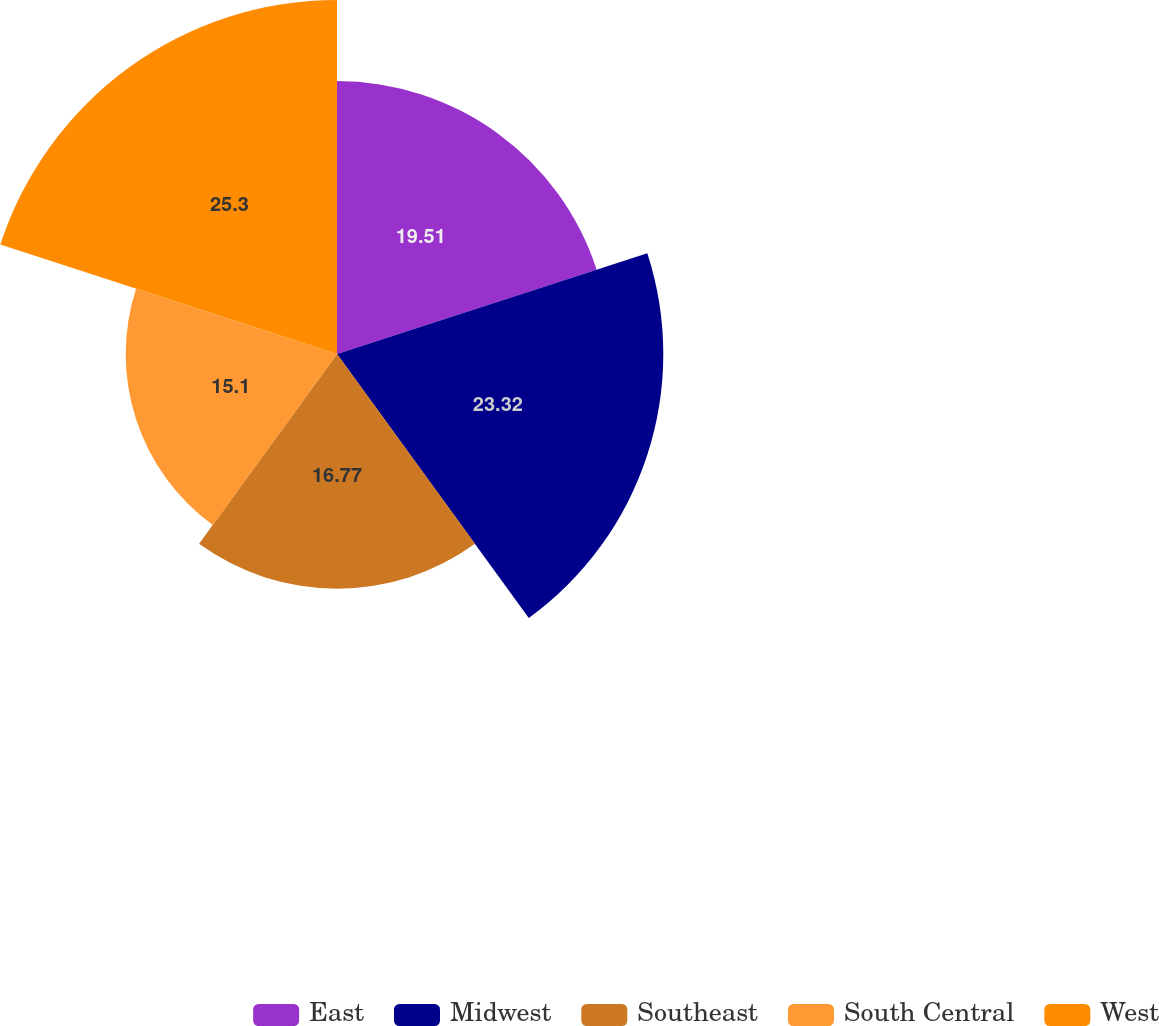Convert chart. <chart><loc_0><loc_0><loc_500><loc_500><pie_chart><fcel>East<fcel>Midwest<fcel>Southeast<fcel>South Central<fcel>West<nl><fcel>19.51%<fcel>23.32%<fcel>16.77%<fcel>15.1%<fcel>25.3%<nl></chart> 